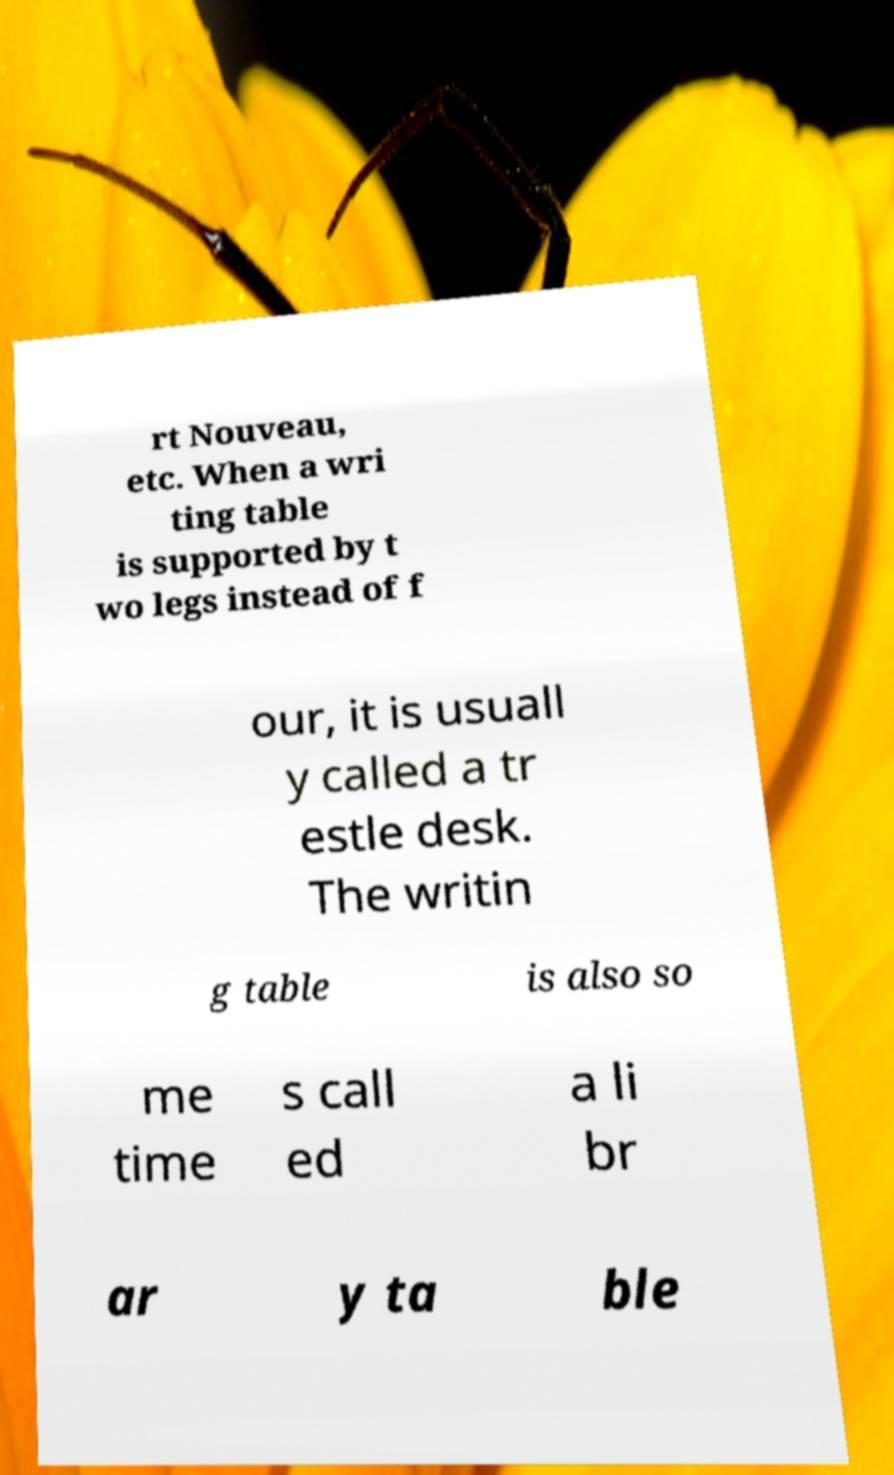There's text embedded in this image that I need extracted. Can you transcribe it verbatim? rt Nouveau, etc. When a wri ting table is supported by t wo legs instead of f our, it is usuall y called a tr estle desk. The writin g table is also so me time s call ed a li br ar y ta ble 